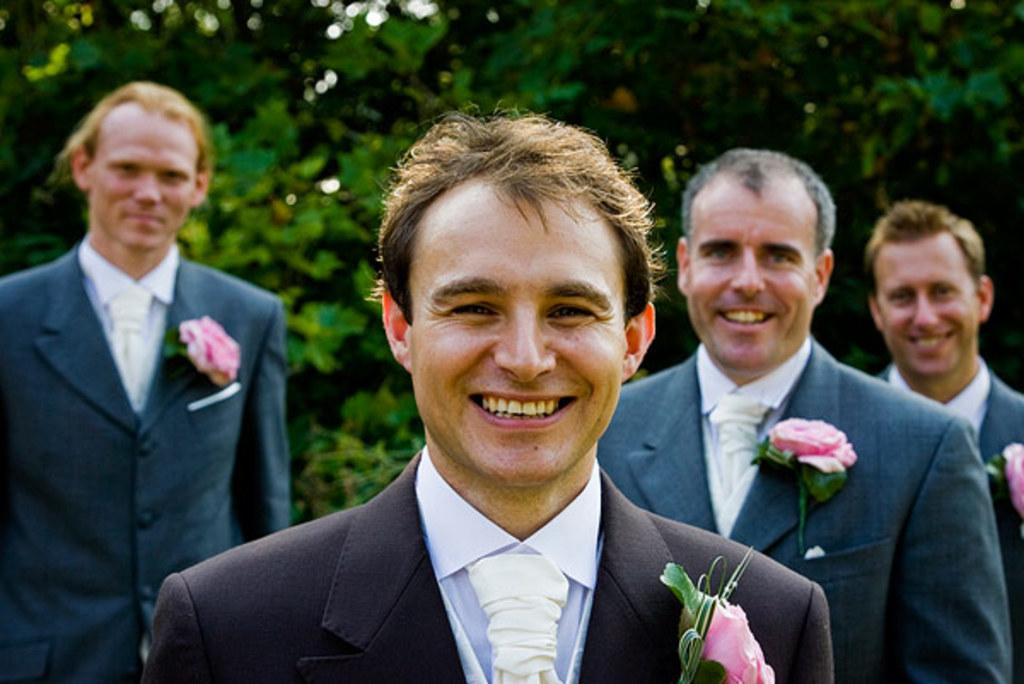How many people are present in the image? There are four people in the image. What are the people wearing in the image? The people are wearing blue jackets. What can be seen in the background of the image? There are trees in the background of the image. Are there any cacti visible in the image? No, there are no cacti present in the image. What type of destruction can be seen in the image? There is no destruction visible in the image; it appears to be a peaceful scene with people wearing blue jackets and trees in the background. 